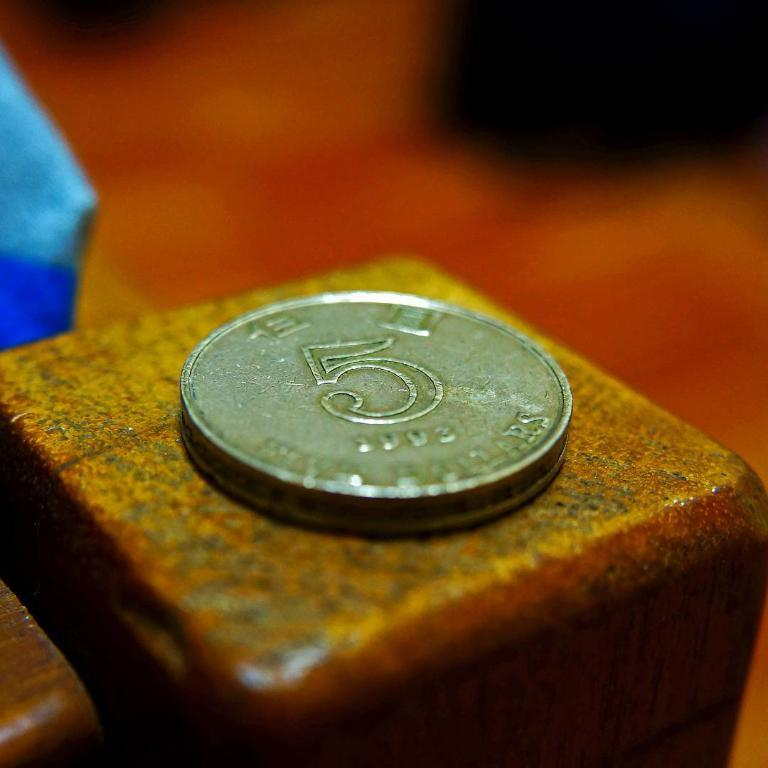<image>
Relay a brief, clear account of the picture shown. a bronze coin with the number 5 and minted in 1992 